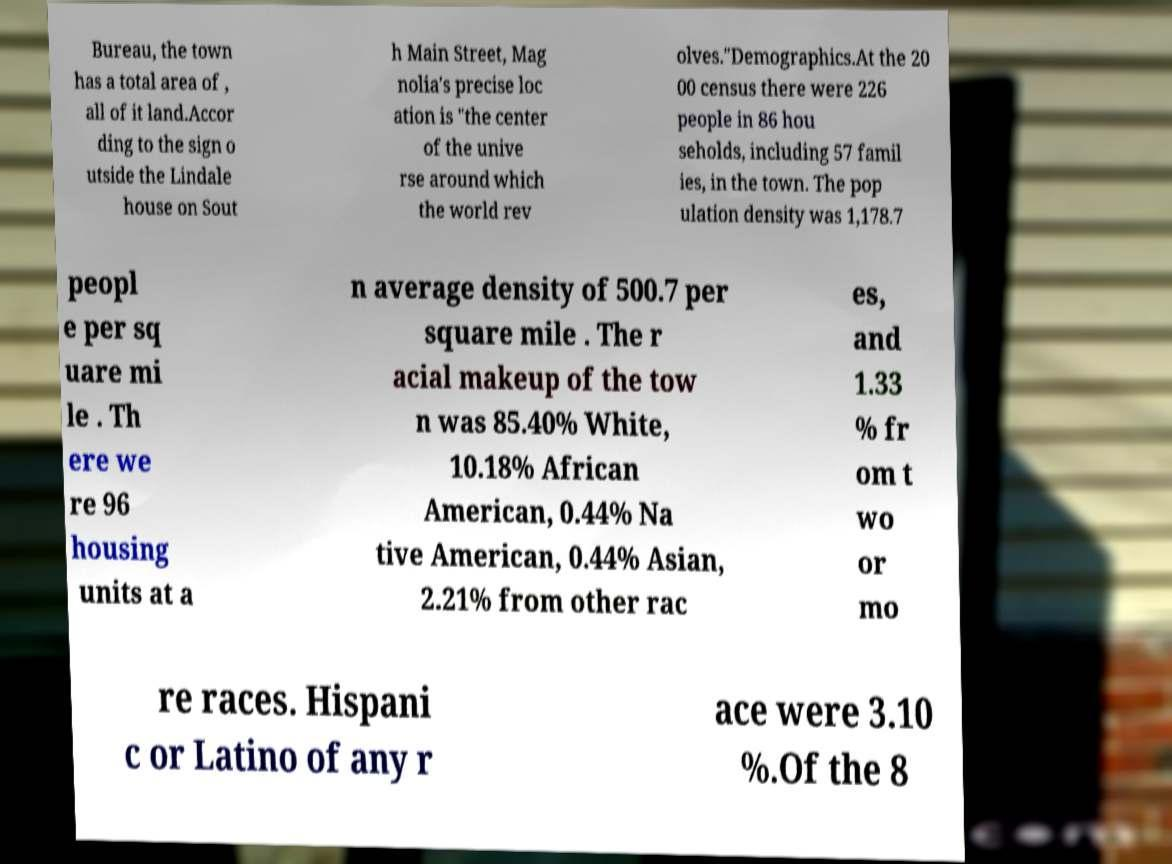Can you read and provide the text displayed in the image?This photo seems to have some interesting text. Can you extract and type it out for me? Bureau, the town has a total area of , all of it land.Accor ding to the sign o utside the Lindale house on Sout h Main Street, Mag nolia's precise loc ation is "the center of the unive rse around which the world rev olves."Demographics.At the 20 00 census there were 226 people in 86 hou seholds, including 57 famil ies, in the town. The pop ulation density was 1,178.7 peopl e per sq uare mi le . Th ere we re 96 housing units at a n average density of 500.7 per square mile . The r acial makeup of the tow n was 85.40% White, 10.18% African American, 0.44% Na tive American, 0.44% Asian, 2.21% from other rac es, and 1.33 % fr om t wo or mo re races. Hispani c or Latino of any r ace were 3.10 %.Of the 8 